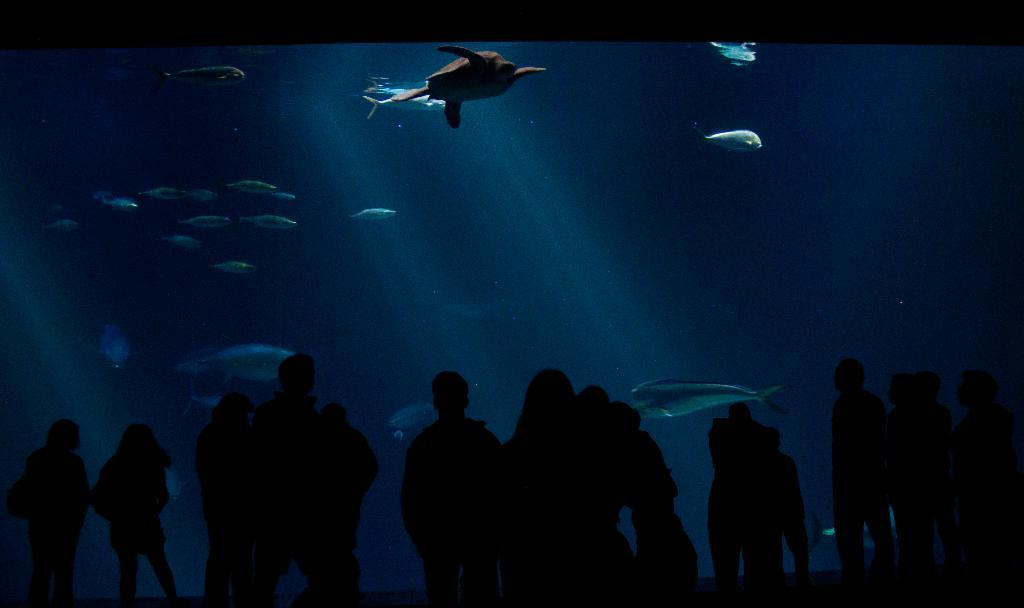What is happening in the image? There are people standing in the image. Can you describe the lighting conditions in the image? The image is taken in a dark environment. What object is present in the image that has a glass component? There is a glass in the image. What can be seen through the glass? A tortoise and fishes swimming in the water are visible through the glass. What type of copper screw can be seen jumping in the image? There is no copper screw present in the image, nor is there any object jumping. 